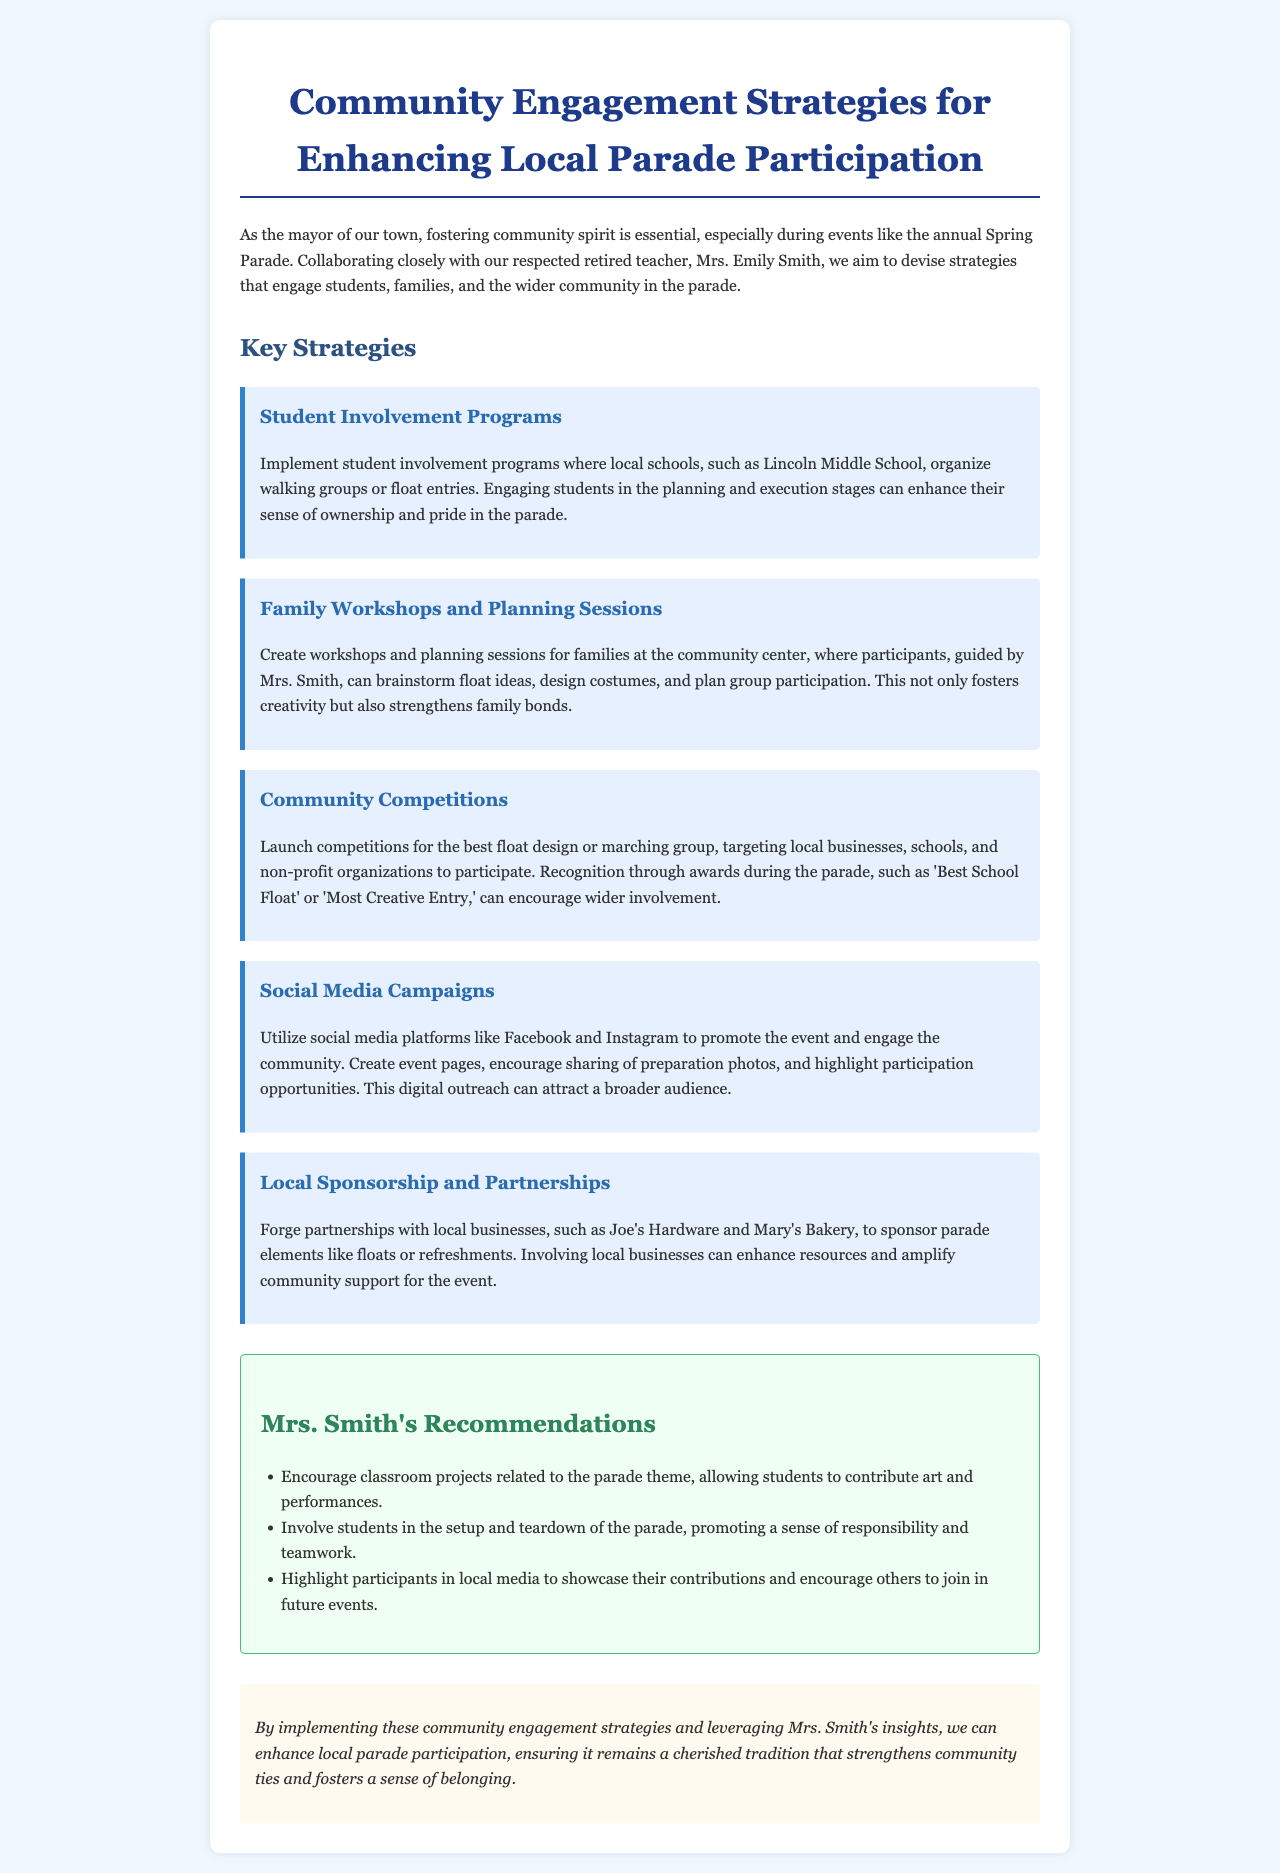What is the title of the document? The title of the document is the heading displayed at the top, summarizing its content.
Answer: Community Engagement Strategies for Enhancing Local Parade Participation Who collaborated with the mayor to devise strategies for the parade? This refers to the person mentioned alongside the mayor in the introduction of the document.
Answer: Mrs. Emily Smith What is one example of a student involvement program mentioned? This can be found in the section discussing specific strategies for involving students in the parade.
Answer: Organize walking groups What type of competitions are suggested in the report? The document references competitions aimed at various community entities for participating in the parade.
Answer: Best float design Which local businesses were mentioned as potential partners for sponsorship? The document lists specific businesses that could aid in supporting the parade.
Answer: Joe's Hardware and Mary's Bakery What is one of Mrs. Smith's recommendations regarding classroom projects? This is specified in the recommendations section of the report, highlighting educational engagement.
Answer: Related to the parade theme What is the primary target audience for the social media campaigns? This is indicated in the strategy outlining how to use social media to engage the community.
Answer: The community How does the report suggest strengthening family bonds? This refers to an activity mentioned in one of the proposed strategies for family involvement.
Answer: Planning sessions at the community center 